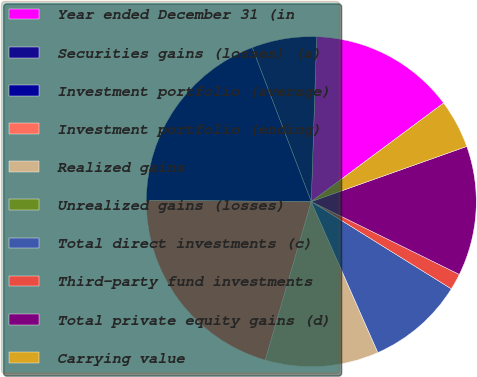<chart> <loc_0><loc_0><loc_500><loc_500><pie_chart><fcel>Year ended December 31 (in<fcel>Securities gains (losses) (a)<fcel>Investment portfolio (average)<fcel>Investment portfolio (ending)<fcel>Realized gains<fcel>Unrealized gains (losses)<fcel>Total direct investments (c)<fcel>Third-party fund investments<fcel>Total private equity gains (d)<fcel>Carrying value<nl><fcel>14.29%<fcel>6.35%<fcel>19.05%<fcel>20.63%<fcel>11.11%<fcel>0.0%<fcel>9.52%<fcel>1.59%<fcel>12.7%<fcel>4.76%<nl></chart> 